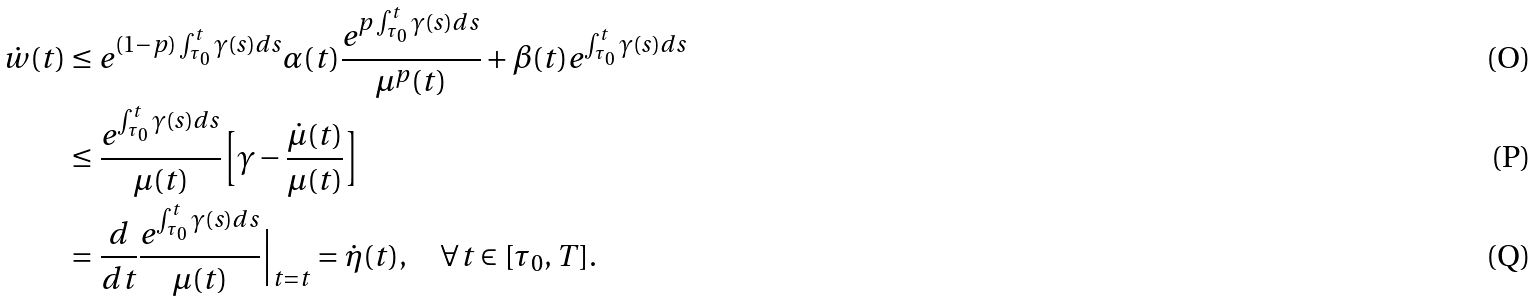Convert formula to latex. <formula><loc_0><loc_0><loc_500><loc_500>\dot { w } ( t ) & \leq e ^ { ( 1 - p ) \int _ { \tau _ { 0 } } ^ { t } \gamma ( s ) d s } \alpha ( t ) \frac { e ^ { p \int _ { \tau _ { 0 } } ^ { t } \gamma ( s ) d s } } { \mu ^ { p } ( t ) } + \beta ( t ) e ^ { \int _ { \tau _ { 0 } } ^ { t } \gamma ( s ) d s } \\ & \leq \frac { e ^ { \int _ { \tau _ { 0 } } ^ { t } \gamma ( s ) d s } } { \mu ( t ) } \Big { [ } \gamma - \frac { \dot { \mu } ( t ) } { \mu ( t ) } \Big { ] } \\ & = \frac { d } { d t } \frac { e ^ { \int _ { \tau _ { 0 } } ^ { t } \gamma ( s ) d s } } { \mu ( t ) } \Big { | } _ { t = t } = \dot { \eta } ( t ) , \quad \forall t \in [ \tau _ { 0 } , T ] .</formula> 